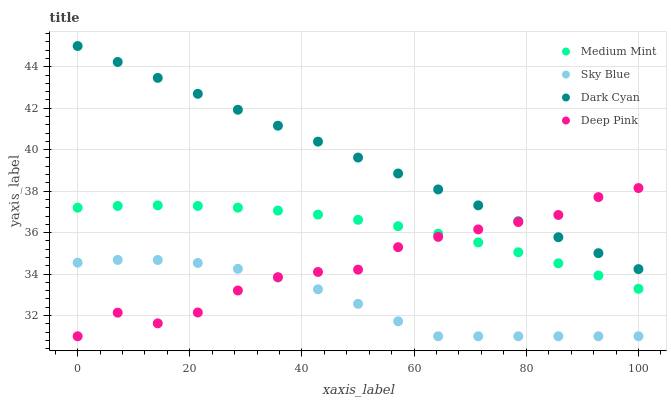Does Sky Blue have the minimum area under the curve?
Answer yes or no. Yes. Does Dark Cyan have the maximum area under the curve?
Answer yes or no. Yes. Does Deep Pink have the minimum area under the curve?
Answer yes or no. No. Does Deep Pink have the maximum area under the curve?
Answer yes or no. No. Is Dark Cyan the smoothest?
Answer yes or no. Yes. Is Deep Pink the roughest?
Answer yes or no. Yes. Is Sky Blue the smoothest?
Answer yes or no. No. Is Sky Blue the roughest?
Answer yes or no. No. Does Sky Blue have the lowest value?
Answer yes or no. Yes. Does Dark Cyan have the lowest value?
Answer yes or no. No. Does Dark Cyan have the highest value?
Answer yes or no. Yes. Does Deep Pink have the highest value?
Answer yes or no. No. Is Sky Blue less than Dark Cyan?
Answer yes or no. Yes. Is Medium Mint greater than Sky Blue?
Answer yes or no. Yes. Does Deep Pink intersect Medium Mint?
Answer yes or no. Yes. Is Deep Pink less than Medium Mint?
Answer yes or no. No. Is Deep Pink greater than Medium Mint?
Answer yes or no. No. Does Sky Blue intersect Dark Cyan?
Answer yes or no. No. 